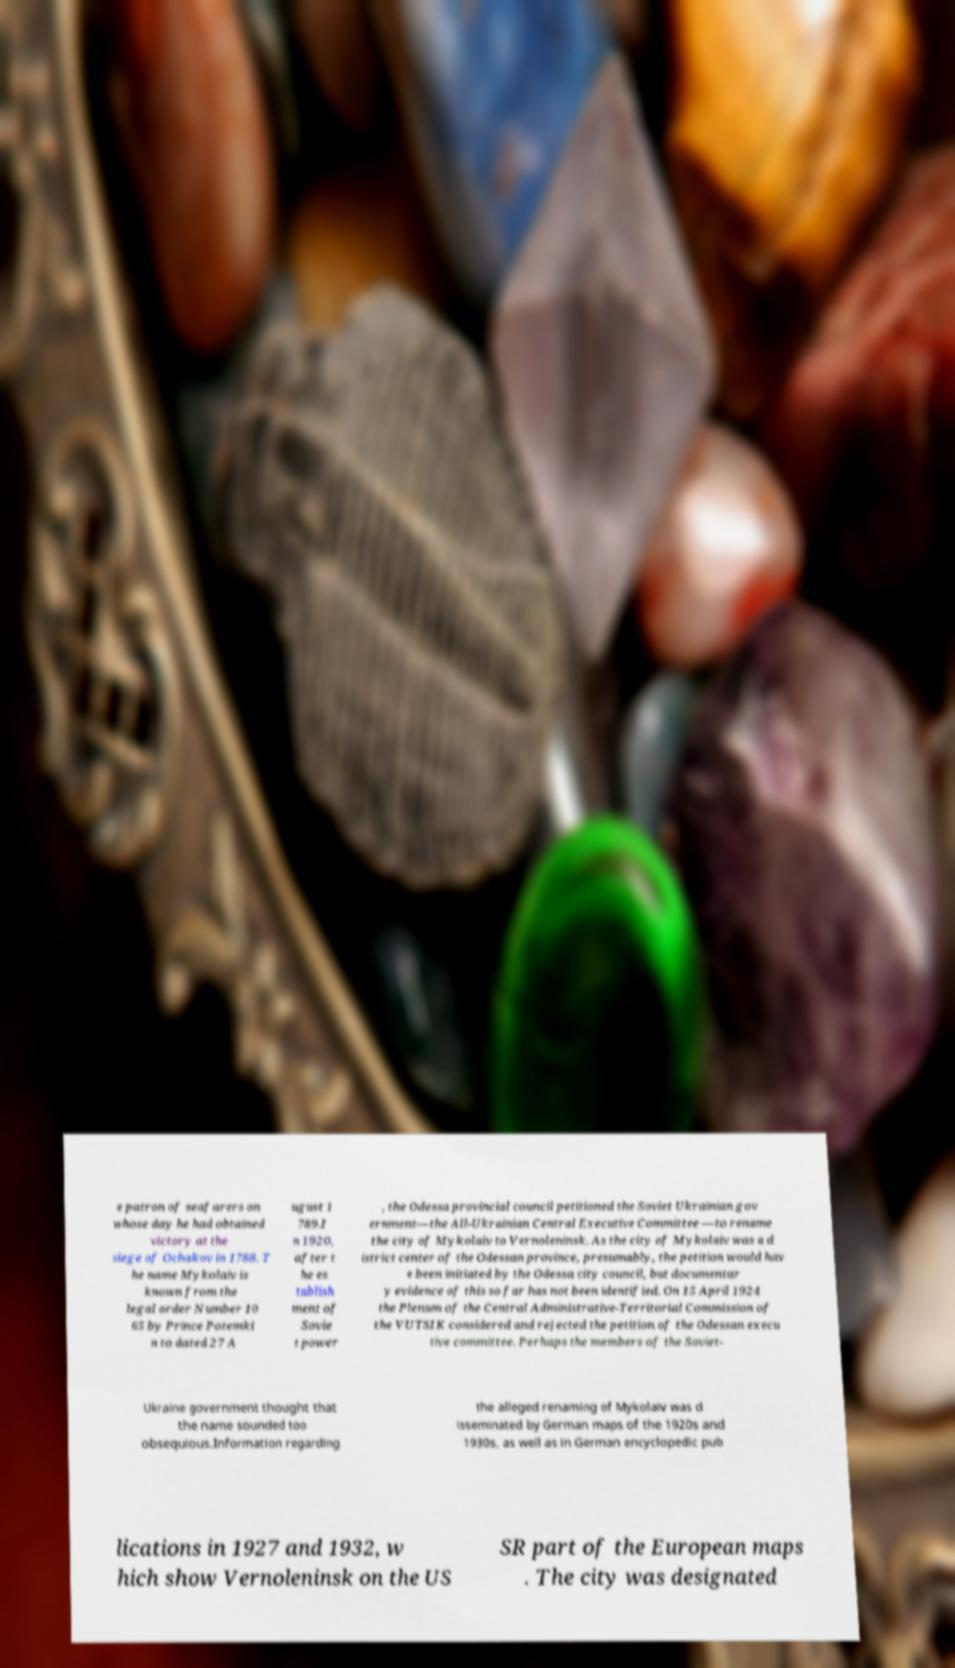Could you assist in decoding the text presented in this image and type it out clearly? e patron of seafarers on whose day he had obtained victory at the siege of Ochakov in 1788. T he name Mykolaiv is known from the legal order Number 10 65 by Prince Potemki n to dated 27 A ugust 1 789.I n 1920, after t he es tablish ment of Sovie t power , the Odessa provincial council petitioned the Soviet Ukrainian gov ernment—the All-Ukrainian Central Executive Committee —to rename the city of Mykolaiv to Vernoleninsk. As the city of Mykolaiv was a d istrict center of the Odessan province, presumably, the petition would hav e been initiated by the Odessa city council, but documentar y evidence of this so far has not been identified. On 15 April 1924 the Plenum of the Central Administrative-Territorial Commission of the VUTSIK considered and rejected the petition of the Odessan execu tive committee. Perhaps the members of the Soviet- Ukraine government thought that the name sounded too obsequious.Information regarding the alleged renaming of Mykolaiv was d isseminated by German maps of the 1920s and 1930s, as well as in German encyclopedic pub lications in 1927 and 1932, w hich show Vernoleninsk on the US SR part of the European maps . The city was designated 